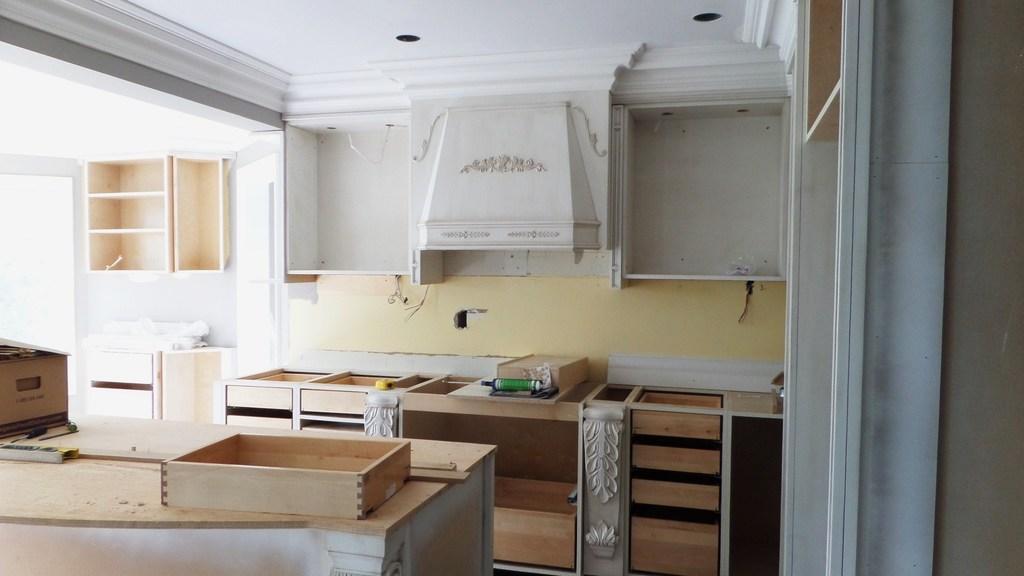Could you give a brief overview of what you see in this image? In this picture we can see wooden boxes, cupboard, here we can see a drilling machine, wooden objects, wall, roof and some objects. 